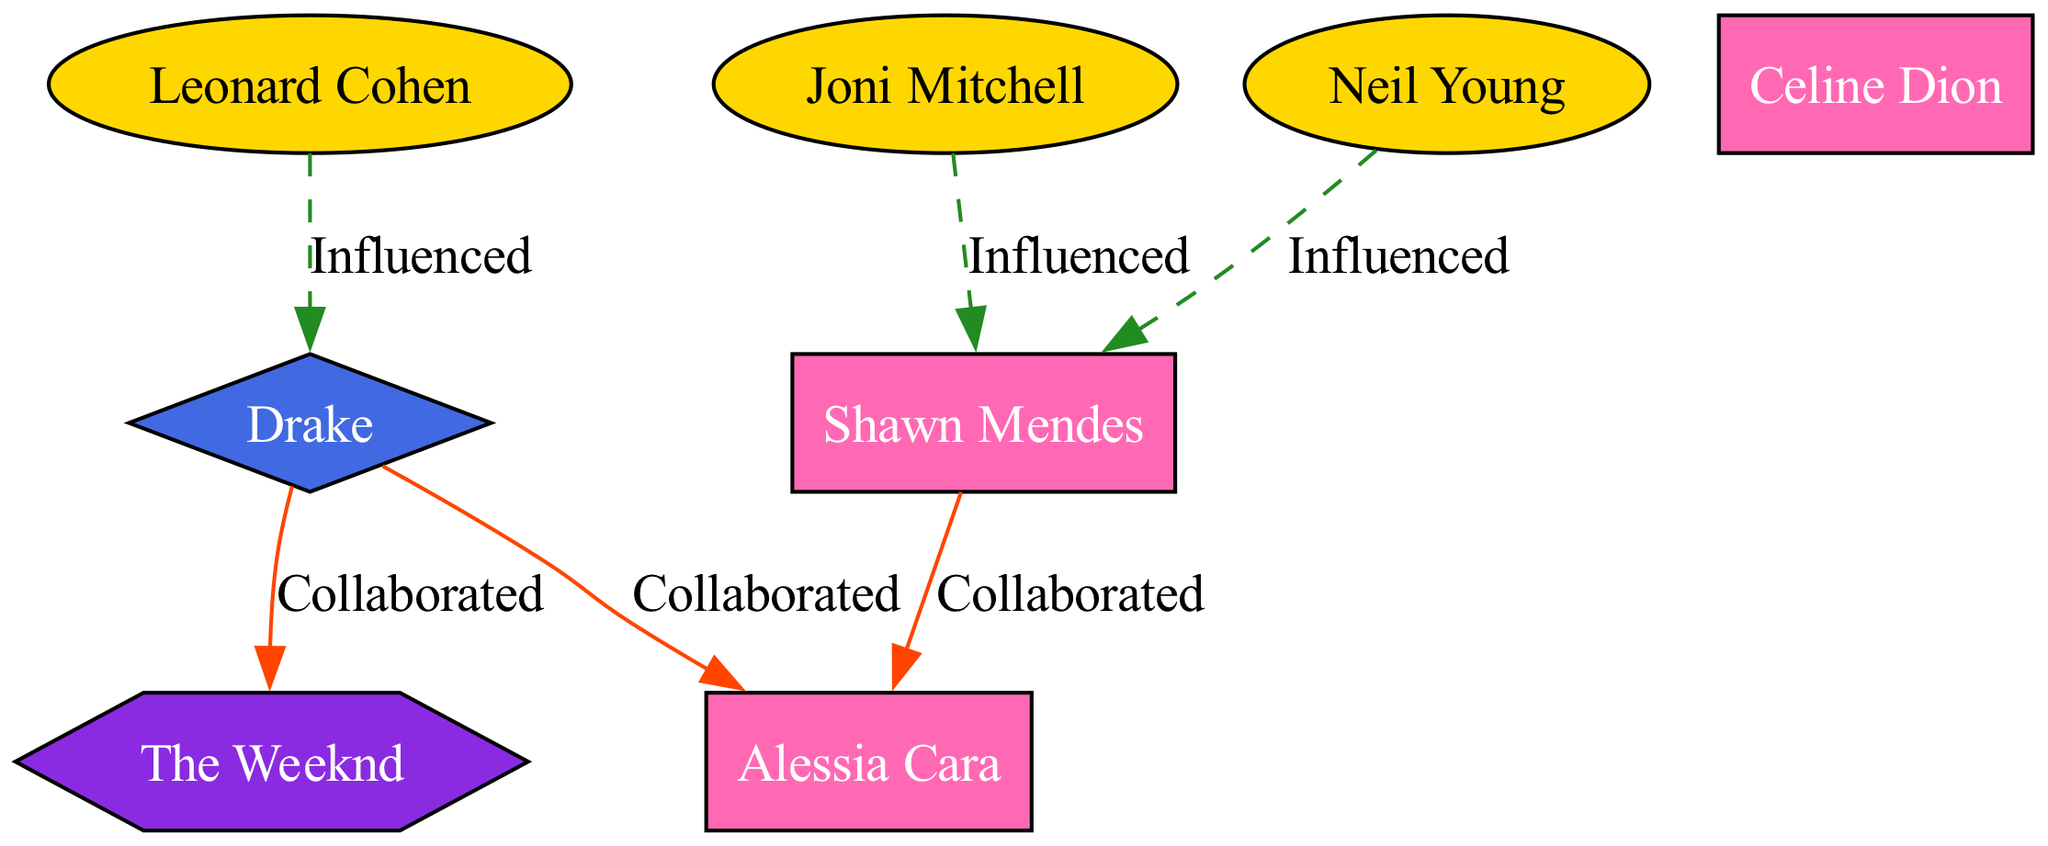What is the total number of influential artists in the diagram? The diagram lists three influential artists: Leonard Cohen, Joni Mitchell, and Neil Young. To find the total, we count these three names.
Answer: 3 Which artist is influenced by Leonard Cohen? In the diagram, the edge originating from Leonard Cohen points to Drake, indicating that Drake is influenced by him.
Answer: Drake Who did Shawn Mendes collaborate with? Shawn Mendes is connected by an edge to Alessia Cara, meaning he collaborated with her. The collaboration is represented by the label on the edge connecting the two.
Answer: Alessia Cara What type of artist is The Weeknd? The diagram categorizes The Weeknd under R&B Artist. This type is explicitly stated in the node description for him.
Answer: R&B Artist Which two artists collaborated with Drake? Both The Weeknd and Alessia Cara are connected to Drake through collaboration edges in the diagram, meaning they worked together with him.
Answer: The Weeknd, Alessia Cara How many collaborations are shown in the diagram? By examining the edges, there are three collaborations: Drake with The Weeknd, Drake with Alessia Cara, and Shawn Mendes with Alessia Cara. Adding these up gives three collaborations.
Answer: 3 Who are the influenced artists from Joni Mitchell? Joni Mitchell influences Shawn Mendes, indicated by a connection from her node to his in the diagram. He is the only influenced artist listed for her.
Answer: Shawn Mendes Which influential artists influenced Shawn Mendes? The diagram shows both Joni Mitchell and Neil Young influencing Shawn Mendes, as indicated by the edges leading to his node.
Answer: Joni Mitchell, Neil Young How is influence represented in the diagram? Influence is represented through dashed edges, which are labeled "Influenced." This type of connection indicates one artist has impacted another's work.
Answer: Dashed edges 